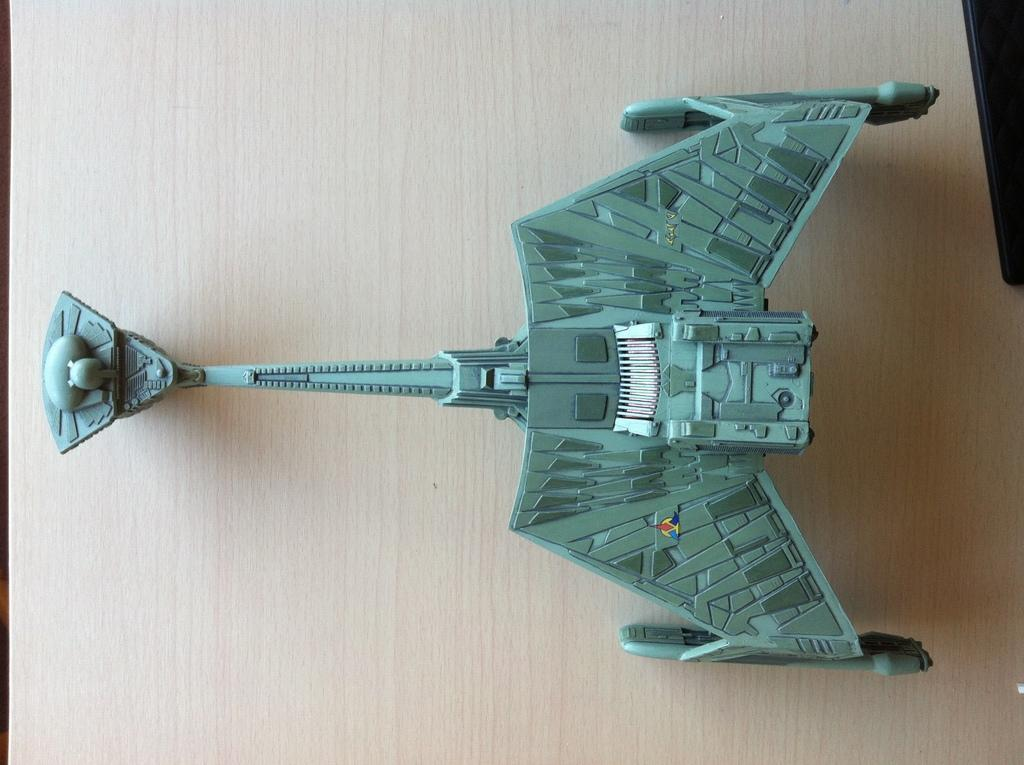What type of object is in the image that resembles a toy? There is a metal object in the image that resembles a toy. Where is the metal object located in the image? The metal object is placed on a table. What can be seen in the top right corner of the image? There is a black color object in the top right of the image. Reasoning: Let'g: Let's think step by step in order to produce the conversation. We start by identifying the main subject in the image, which is the metal object that resembles a toy. Then, we describe its location, which is on a table. Finally, we mention the black color object in the top right corner of the image. Each question is designed to elicit a specific detail about the image that is known from the provided facts. Absurd Question/Answer: What type of yoke is being used to invent a new heart in the image? There is no yoke, invention, or heart present in the image. 